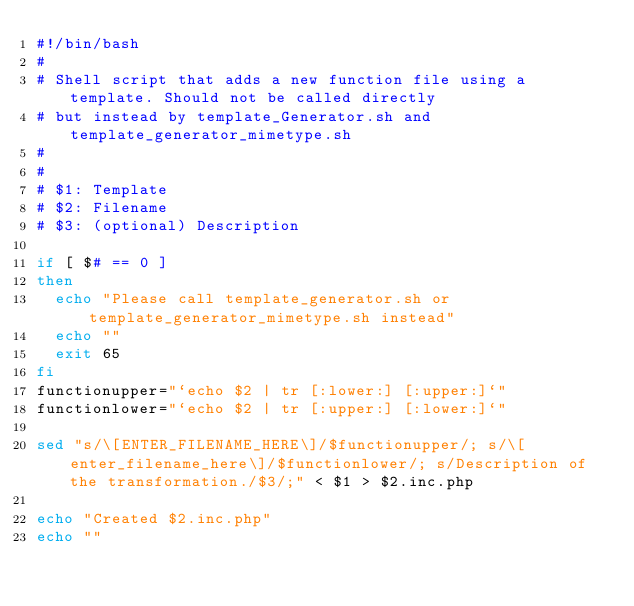Convert code to text. <code><loc_0><loc_0><loc_500><loc_500><_Bash_>#!/bin/bash
#
# Shell script that adds a new function file using a template. Should not be called directly
# but instead by template_Generator.sh and template_generator_mimetype.sh
#
#
# $1: Template
# $2: Filename
# $3: (optional) Description

if [ $# == 0 ]
then
  echo "Please call template_generator.sh or template_generator_mimetype.sh instead"
  echo ""
  exit 65
fi
functionupper="`echo $2 | tr [:lower:] [:upper:]`"
functionlower="`echo $2 | tr [:upper:] [:lower:]`"

sed "s/\[ENTER_FILENAME_HERE\]/$functionupper/; s/\[enter_filename_here\]/$functionlower/; s/Description of the transformation./$3/;" < $1 > $2.inc.php

echo "Created $2.inc.php"
echo ""
</code> 